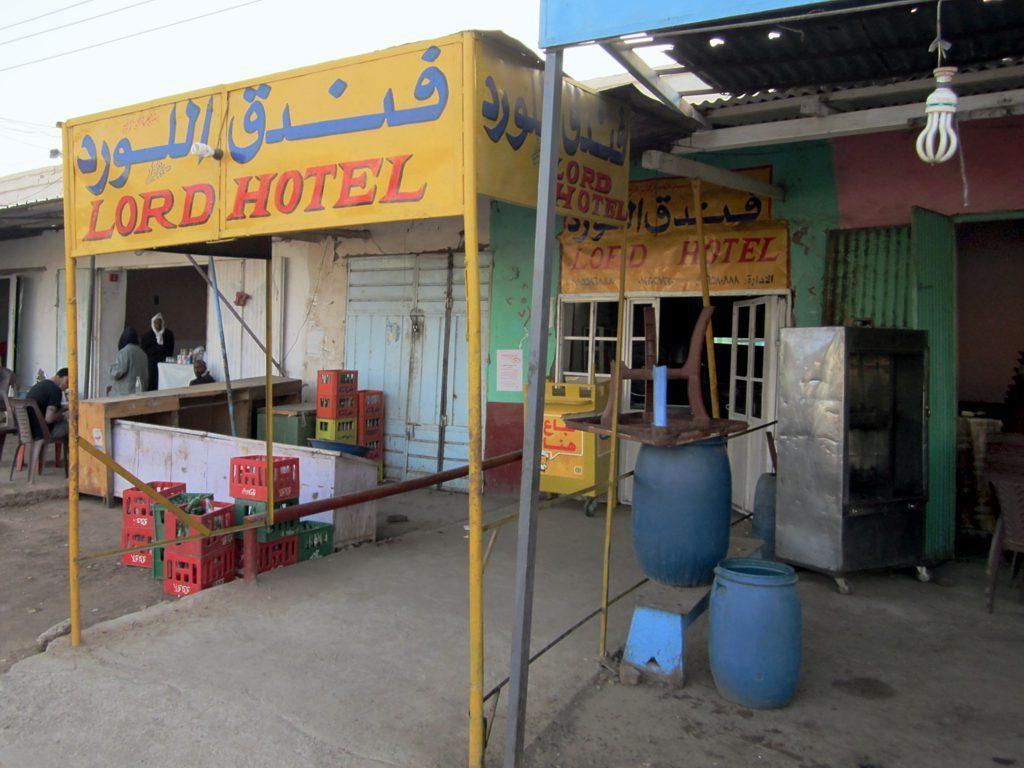Could you give a brief overview of what you see in this image? At the right side of the image there is a store with door, blue drums, steel item, also there is a bulb at the top of the image with a roof. Beside that there is another store with yellow poster, glass doors, poles with yellow boards and few other items. In the background there are red and green boxes, tables and few people are there. At the top of the image there is a sky. 